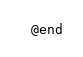<code> <loc_0><loc_0><loc_500><loc_500><_C_>@end
</code> 